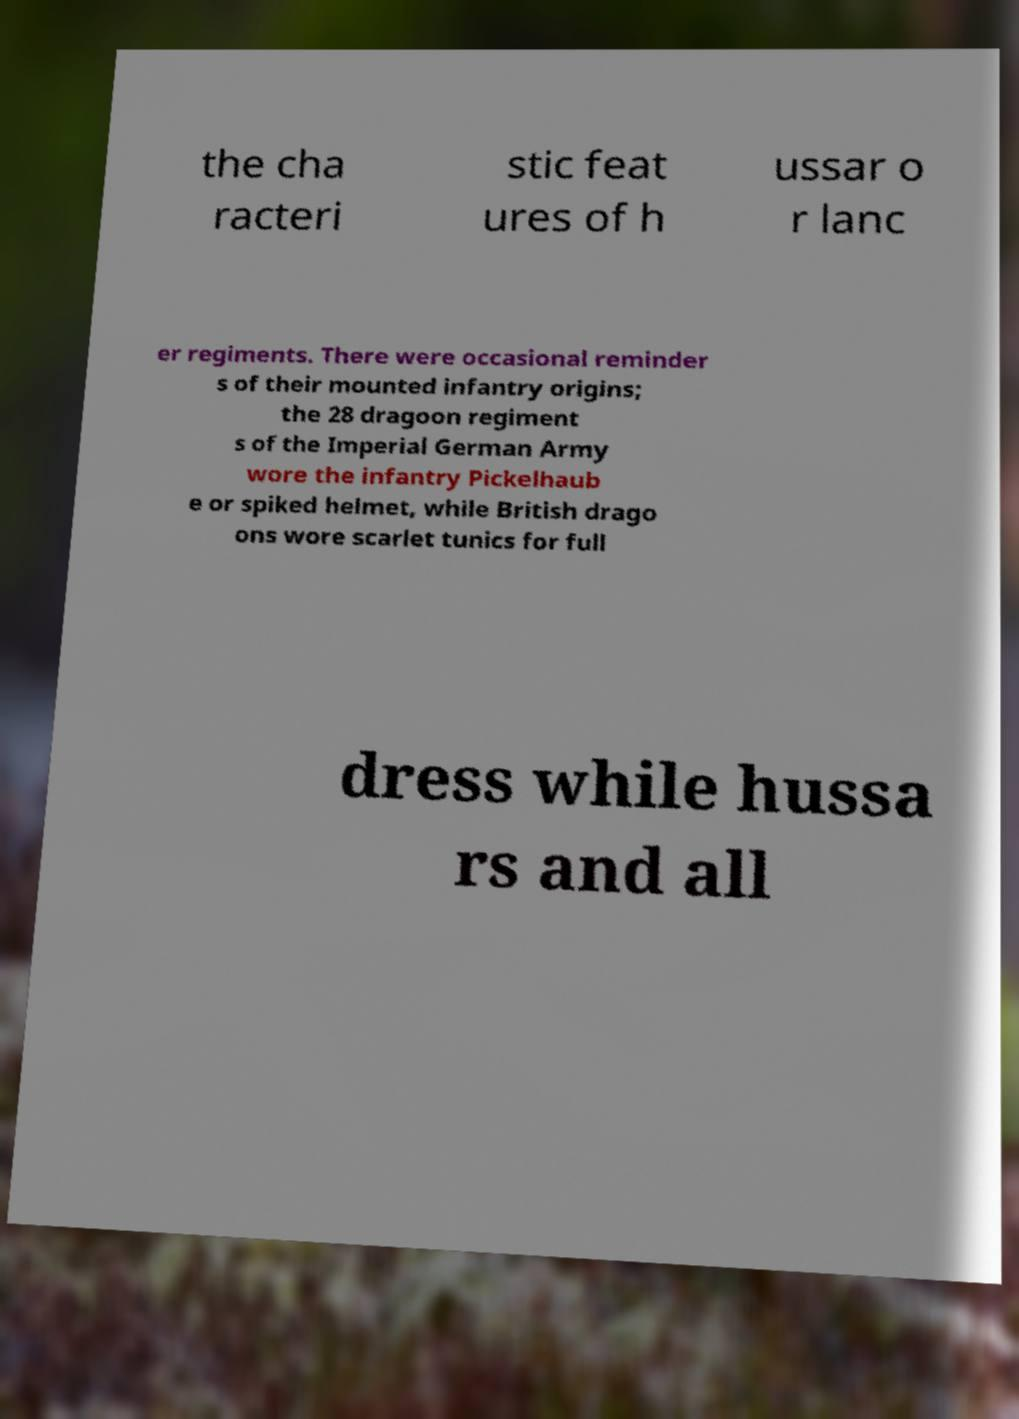Please identify and transcribe the text found in this image. the cha racteri stic feat ures of h ussar o r lanc er regiments. There were occasional reminder s of their mounted infantry origins; the 28 dragoon regiment s of the Imperial German Army wore the infantry Pickelhaub e or spiked helmet, while British drago ons wore scarlet tunics for full dress while hussa rs and all 